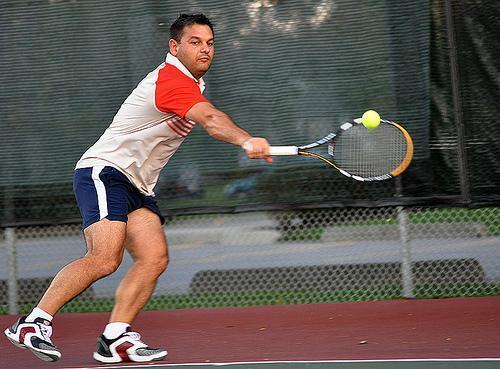How many people are there?
Give a very brief answer. 1. 